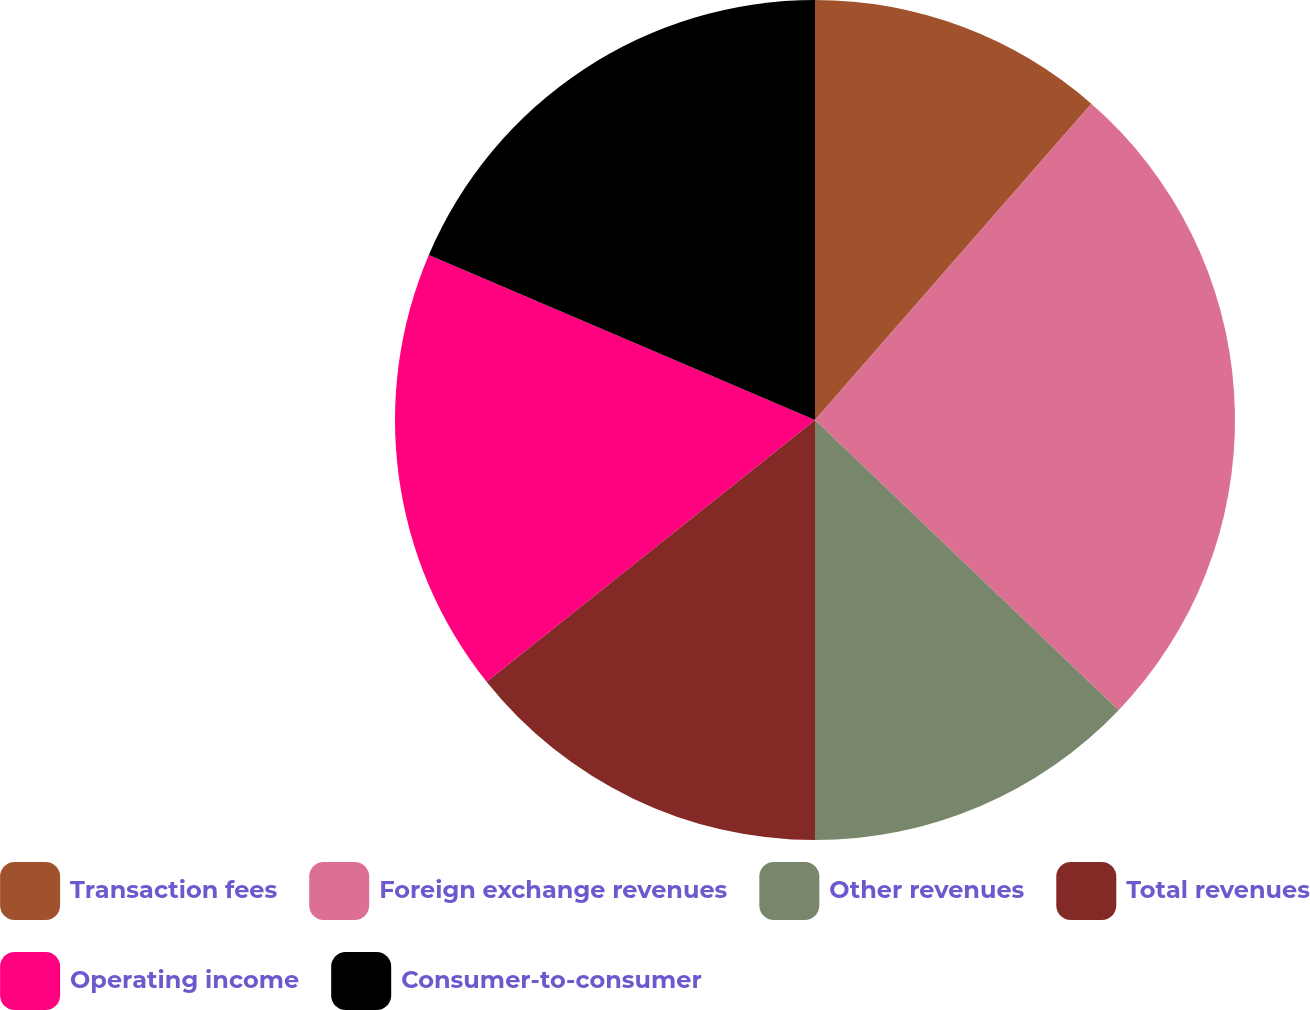Convert chart to OTSL. <chart><loc_0><loc_0><loc_500><loc_500><pie_chart><fcel>Transaction fees<fcel>Foreign exchange revenues<fcel>Other revenues<fcel>Total revenues<fcel>Operating income<fcel>Consumer-to-consumer<nl><fcel>11.43%<fcel>25.71%<fcel>12.86%<fcel>14.29%<fcel>17.14%<fcel>18.57%<nl></chart> 